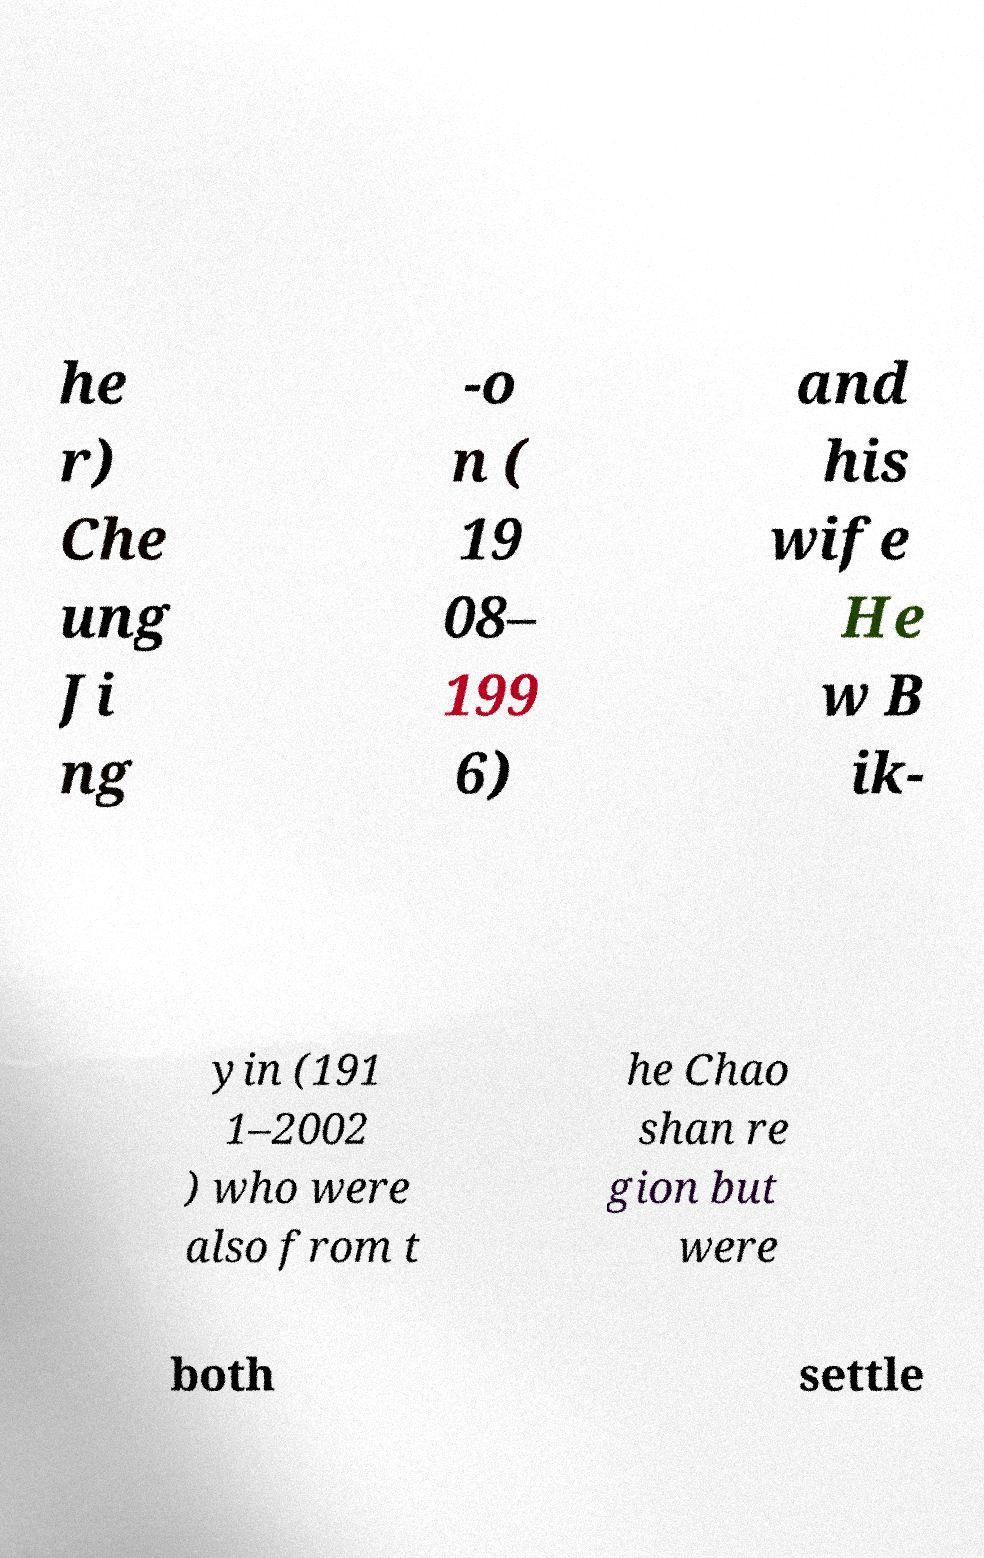Can you accurately transcribe the text from the provided image for me? he r) Che ung Ji ng -o n ( 19 08– 199 6) and his wife He w B ik- yin (191 1–2002 ) who were also from t he Chao shan re gion but were both settle 